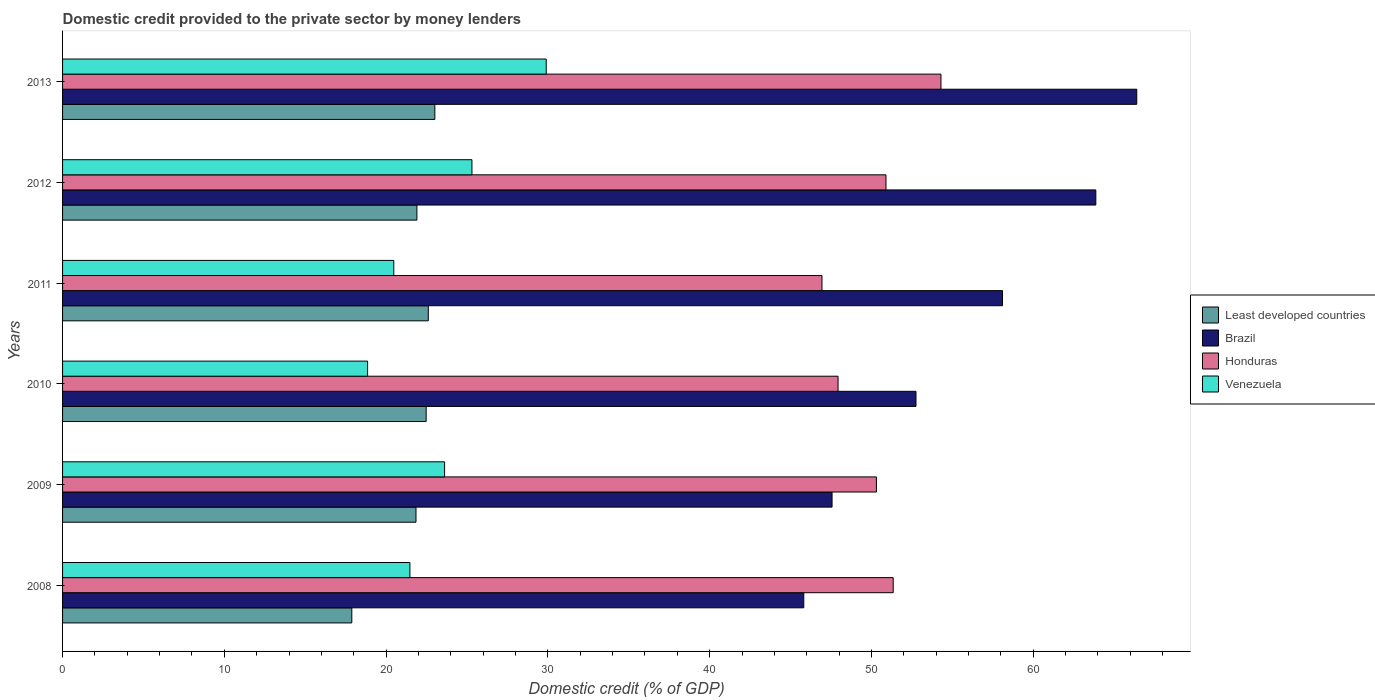How many different coloured bars are there?
Your response must be concise. 4. How many groups of bars are there?
Your response must be concise. 6. Are the number of bars per tick equal to the number of legend labels?
Your answer should be compact. Yes. How many bars are there on the 2nd tick from the top?
Make the answer very short. 4. How many bars are there on the 2nd tick from the bottom?
Your answer should be compact. 4. In how many cases, is the number of bars for a given year not equal to the number of legend labels?
Offer a very short reply. 0. What is the domestic credit provided to the private sector by money lenders in Honduras in 2010?
Provide a short and direct response. 47.93. Across all years, what is the maximum domestic credit provided to the private sector by money lenders in Brazil?
Keep it short and to the point. 66.4. Across all years, what is the minimum domestic credit provided to the private sector by money lenders in Least developed countries?
Give a very brief answer. 17.88. What is the total domestic credit provided to the private sector by money lenders in Brazil in the graph?
Your answer should be compact. 334.5. What is the difference between the domestic credit provided to the private sector by money lenders in Least developed countries in 2011 and that in 2012?
Ensure brevity in your answer.  0.7. What is the difference between the domestic credit provided to the private sector by money lenders in Brazil in 2010 and the domestic credit provided to the private sector by money lenders in Honduras in 2009?
Provide a short and direct response. 2.45. What is the average domestic credit provided to the private sector by money lenders in Least developed countries per year?
Your answer should be compact. 21.62. In the year 2013, what is the difference between the domestic credit provided to the private sector by money lenders in Venezuela and domestic credit provided to the private sector by money lenders in Brazil?
Offer a very short reply. -36.5. What is the ratio of the domestic credit provided to the private sector by money lenders in Brazil in 2011 to that in 2013?
Keep it short and to the point. 0.88. What is the difference between the highest and the second highest domestic credit provided to the private sector by money lenders in Least developed countries?
Your answer should be compact. 0.4. What is the difference between the highest and the lowest domestic credit provided to the private sector by money lenders in Venezuela?
Provide a succinct answer. 11.04. In how many years, is the domestic credit provided to the private sector by money lenders in Honduras greater than the average domestic credit provided to the private sector by money lenders in Honduras taken over all years?
Provide a succinct answer. 4. Is the sum of the domestic credit provided to the private sector by money lenders in Least developed countries in 2008 and 2012 greater than the maximum domestic credit provided to the private sector by money lenders in Honduras across all years?
Keep it short and to the point. No. What does the 3rd bar from the top in 2009 represents?
Keep it short and to the point. Brazil. What does the 4th bar from the bottom in 2012 represents?
Make the answer very short. Venezuela. How many bars are there?
Offer a very short reply. 24. Where does the legend appear in the graph?
Provide a short and direct response. Center right. What is the title of the graph?
Offer a very short reply. Domestic credit provided to the private sector by money lenders. What is the label or title of the X-axis?
Provide a succinct answer. Domestic credit (% of GDP). What is the Domestic credit (% of GDP) of Least developed countries in 2008?
Make the answer very short. 17.88. What is the Domestic credit (% of GDP) of Brazil in 2008?
Keep it short and to the point. 45.82. What is the Domestic credit (% of GDP) in Honduras in 2008?
Ensure brevity in your answer.  51.34. What is the Domestic credit (% of GDP) in Venezuela in 2008?
Provide a short and direct response. 21.47. What is the Domestic credit (% of GDP) in Least developed countries in 2009?
Ensure brevity in your answer.  21.85. What is the Domestic credit (% of GDP) of Brazil in 2009?
Keep it short and to the point. 47.56. What is the Domestic credit (% of GDP) in Honduras in 2009?
Your answer should be compact. 50.31. What is the Domestic credit (% of GDP) of Venezuela in 2009?
Keep it short and to the point. 23.61. What is the Domestic credit (% of GDP) in Least developed countries in 2010?
Give a very brief answer. 22.47. What is the Domestic credit (% of GDP) in Brazil in 2010?
Make the answer very short. 52.75. What is the Domestic credit (% of GDP) in Honduras in 2010?
Keep it short and to the point. 47.93. What is the Domestic credit (% of GDP) of Venezuela in 2010?
Give a very brief answer. 18.85. What is the Domestic credit (% of GDP) in Least developed countries in 2011?
Your answer should be very brief. 22.61. What is the Domestic credit (% of GDP) of Brazil in 2011?
Keep it short and to the point. 58.1. What is the Domestic credit (% of GDP) of Honduras in 2011?
Provide a succinct answer. 46.94. What is the Domestic credit (% of GDP) of Venezuela in 2011?
Provide a succinct answer. 20.47. What is the Domestic credit (% of GDP) of Least developed countries in 2012?
Offer a very short reply. 21.9. What is the Domestic credit (% of GDP) of Brazil in 2012?
Keep it short and to the point. 63.87. What is the Domestic credit (% of GDP) in Honduras in 2012?
Provide a succinct answer. 50.9. What is the Domestic credit (% of GDP) in Venezuela in 2012?
Ensure brevity in your answer.  25.3. What is the Domestic credit (% of GDP) in Least developed countries in 2013?
Keep it short and to the point. 23.01. What is the Domestic credit (% of GDP) of Brazil in 2013?
Offer a terse response. 66.4. What is the Domestic credit (% of GDP) in Honduras in 2013?
Provide a succinct answer. 54.3. What is the Domestic credit (% of GDP) of Venezuela in 2013?
Provide a succinct answer. 29.9. Across all years, what is the maximum Domestic credit (% of GDP) of Least developed countries?
Offer a very short reply. 23.01. Across all years, what is the maximum Domestic credit (% of GDP) of Brazil?
Make the answer very short. 66.4. Across all years, what is the maximum Domestic credit (% of GDP) in Honduras?
Make the answer very short. 54.3. Across all years, what is the maximum Domestic credit (% of GDP) of Venezuela?
Offer a terse response. 29.9. Across all years, what is the minimum Domestic credit (% of GDP) of Least developed countries?
Keep it short and to the point. 17.88. Across all years, what is the minimum Domestic credit (% of GDP) of Brazil?
Ensure brevity in your answer.  45.82. Across all years, what is the minimum Domestic credit (% of GDP) of Honduras?
Ensure brevity in your answer.  46.94. Across all years, what is the minimum Domestic credit (% of GDP) in Venezuela?
Offer a terse response. 18.85. What is the total Domestic credit (% of GDP) in Least developed countries in the graph?
Your answer should be very brief. 129.72. What is the total Domestic credit (% of GDP) in Brazil in the graph?
Keep it short and to the point. 334.5. What is the total Domestic credit (% of GDP) of Honduras in the graph?
Ensure brevity in your answer.  301.72. What is the total Domestic credit (% of GDP) of Venezuela in the graph?
Make the answer very short. 139.61. What is the difference between the Domestic credit (% of GDP) of Least developed countries in 2008 and that in 2009?
Offer a very short reply. -3.97. What is the difference between the Domestic credit (% of GDP) in Brazil in 2008 and that in 2009?
Your answer should be compact. -1.75. What is the difference between the Domestic credit (% of GDP) in Honduras in 2008 and that in 2009?
Give a very brief answer. 1.04. What is the difference between the Domestic credit (% of GDP) of Venezuela in 2008 and that in 2009?
Your response must be concise. -2.14. What is the difference between the Domestic credit (% of GDP) in Least developed countries in 2008 and that in 2010?
Your answer should be compact. -4.6. What is the difference between the Domestic credit (% of GDP) in Brazil in 2008 and that in 2010?
Give a very brief answer. -6.94. What is the difference between the Domestic credit (% of GDP) of Honduras in 2008 and that in 2010?
Give a very brief answer. 3.41. What is the difference between the Domestic credit (% of GDP) in Venezuela in 2008 and that in 2010?
Your answer should be very brief. 2.62. What is the difference between the Domestic credit (% of GDP) in Least developed countries in 2008 and that in 2011?
Provide a short and direct response. -4.73. What is the difference between the Domestic credit (% of GDP) of Brazil in 2008 and that in 2011?
Your answer should be very brief. -12.28. What is the difference between the Domestic credit (% of GDP) of Honduras in 2008 and that in 2011?
Make the answer very short. 4.4. What is the difference between the Domestic credit (% of GDP) in Least developed countries in 2008 and that in 2012?
Give a very brief answer. -4.02. What is the difference between the Domestic credit (% of GDP) in Brazil in 2008 and that in 2012?
Your response must be concise. -18.05. What is the difference between the Domestic credit (% of GDP) of Honduras in 2008 and that in 2012?
Provide a succinct answer. 0.45. What is the difference between the Domestic credit (% of GDP) of Venezuela in 2008 and that in 2012?
Make the answer very short. -3.83. What is the difference between the Domestic credit (% of GDP) in Least developed countries in 2008 and that in 2013?
Keep it short and to the point. -5.13. What is the difference between the Domestic credit (% of GDP) of Brazil in 2008 and that in 2013?
Offer a very short reply. -20.58. What is the difference between the Domestic credit (% of GDP) in Honduras in 2008 and that in 2013?
Ensure brevity in your answer.  -2.95. What is the difference between the Domestic credit (% of GDP) in Venezuela in 2008 and that in 2013?
Your answer should be compact. -8.43. What is the difference between the Domestic credit (% of GDP) in Least developed countries in 2009 and that in 2010?
Give a very brief answer. -0.63. What is the difference between the Domestic credit (% of GDP) in Brazil in 2009 and that in 2010?
Offer a terse response. -5.19. What is the difference between the Domestic credit (% of GDP) of Honduras in 2009 and that in 2010?
Ensure brevity in your answer.  2.37. What is the difference between the Domestic credit (% of GDP) of Venezuela in 2009 and that in 2010?
Your answer should be compact. 4.76. What is the difference between the Domestic credit (% of GDP) of Least developed countries in 2009 and that in 2011?
Provide a succinct answer. -0.76. What is the difference between the Domestic credit (% of GDP) of Brazil in 2009 and that in 2011?
Provide a short and direct response. -10.54. What is the difference between the Domestic credit (% of GDP) in Honduras in 2009 and that in 2011?
Your response must be concise. 3.37. What is the difference between the Domestic credit (% of GDP) in Venezuela in 2009 and that in 2011?
Your response must be concise. 3.14. What is the difference between the Domestic credit (% of GDP) of Least developed countries in 2009 and that in 2012?
Keep it short and to the point. -0.06. What is the difference between the Domestic credit (% of GDP) of Brazil in 2009 and that in 2012?
Ensure brevity in your answer.  -16.3. What is the difference between the Domestic credit (% of GDP) of Honduras in 2009 and that in 2012?
Offer a very short reply. -0.59. What is the difference between the Domestic credit (% of GDP) in Venezuela in 2009 and that in 2012?
Your response must be concise. -1.69. What is the difference between the Domestic credit (% of GDP) of Least developed countries in 2009 and that in 2013?
Give a very brief answer. -1.16. What is the difference between the Domestic credit (% of GDP) in Brazil in 2009 and that in 2013?
Offer a terse response. -18.83. What is the difference between the Domestic credit (% of GDP) in Honduras in 2009 and that in 2013?
Your response must be concise. -3.99. What is the difference between the Domestic credit (% of GDP) of Venezuela in 2009 and that in 2013?
Offer a terse response. -6.28. What is the difference between the Domestic credit (% of GDP) in Least developed countries in 2010 and that in 2011?
Provide a short and direct response. -0.13. What is the difference between the Domestic credit (% of GDP) in Brazil in 2010 and that in 2011?
Your answer should be compact. -5.35. What is the difference between the Domestic credit (% of GDP) in Honduras in 2010 and that in 2011?
Ensure brevity in your answer.  0.99. What is the difference between the Domestic credit (% of GDP) in Venezuela in 2010 and that in 2011?
Offer a terse response. -1.62. What is the difference between the Domestic credit (% of GDP) in Least developed countries in 2010 and that in 2012?
Your answer should be very brief. 0.57. What is the difference between the Domestic credit (% of GDP) in Brazil in 2010 and that in 2012?
Your response must be concise. -11.12. What is the difference between the Domestic credit (% of GDP) of Honduras in 2010 and that in 2012?
Keep it short and to the point. -2.96. What is the difference between the Domestic credit (% of GDP) of Venezuela in 2010 and that in 2012?
Keep it short and to the point. -6.45. What is the difference between the Domestic credit (% of GDP) in Least developed countries in 2010 and that in 2013?
Make the answer very short. -0.54. What is the difference between the Domestic credit (% of GDP) of Brazil in 2010 and that in 2013?
Provide a short and direct response. -13.65. What is the difference between the Domestic credit (% of GDP) of Honduras in 2010 and that in 2013?
Keep it short and to the point. -6.36. What is the difference between the Domestic credit (% of GDP) of Venezuela in 2010 and that in 2013?
Make the answer very short. -11.04. What is the difference between the Domestic credit (% of GDP) in Least developed countries in 2011 and that in 2012?
Ensure brevity in your answer.  0.7. What is the difference between the Domestic credit (% of GDP) of Brazil in 2011 and that in 2012?
Your answer should be compact. -5.77. What is the difference between the Domestic credit (% of GDP) in Honduras in 2011 and that in 2012?
Offer a terse response. -3.96. What is the difference between the Domestic credit (% of GDP) of Venezuela in 2011 and that in 2012?
Give a very brief answer. -4.83. What is the difference between the Domestic credit (% of GDP) in Least developed countries in 2011 and that in 2013?
Make the answer very short. -0.4. What is the difference between the Domestic credit (% of GDP) in Brazil in 2011 and that in 2013?
Offer a very short reply. -8.3. What is the difference between the Domestic credit (% of GDP) in Honduras in 2011 and that in 2013?
Offer a very short reply. -7.36. What is the difference between the Domestic credit (% of GDP) in Venezuela in 2011 and that in 2013?
Make the answer very short. -9.42. What is the difference between the Domestic credit (% of GDP) of Least developed countries in 2012 and that in 2013?
Offer a very short reply. -1.11. What is the difference between the Domestic credit (% of GDP) of Brazil in 2012 and that in 2013?
Provide a succinct answer. -2.53. What is the difference between the Domestic credit (% of GDP) of Honduras in 2012 and that in 2013?
Your answer should be very brief. -3.4. What is the difference between the Domestic credit (% of GDP) in Venezuela in 2012 and that in 2013?
Your response must be concise. -4.59. What is the difference between the Domestic credit (% of GDP) in Least developed countries in 2008 and the Domestic credit (% of GDP) in Brazil in 2009?
Provide a short and direct response. -29.68. What is the difference between the Domestic credit (% of GDP) in Least developed countries in 2008 and the Domestic credit (% of GDP) in Honduras in 2009?
Ensure brevity in your answer.  -32.43. What is the difference between the Domestic credit (% of GDP) of Least developed countries in 2008 and the Domestic credit (% of GDP) of Venezuela in 2009?
Make the answer very short. -5.73. What is the difference between the Domestic credit (% of GDP) of Brazil in 2008 and the Domestic credit (% of GDP) of Honduras in 2009?
Offer a very short reply. -4.49. What is the difference between the Domestic credit (% of GDP) in Brazil in 2008 and the Domestic credit (% of GDP) in Venezuela in 2009?
Your response must be concise. 22.2. What is the difference between the Domestic credit (% of GDP) in Honduras in 2008 and the Domestic credit (% of GDP) in Venezuela in 2009?
Your answer should be compact. 27.73. What is the difference between the Domestic credit (% of GDP) of Least developed countries in 2008 and the Domestic credit (% of GDP) of Brazil in 2010?
Keep it short and to the point. -34.87. What is the difference between the Domestic credit (% of GDP) in Least developed countries in 2008 and the Domestic credit (% of GDP) in Honduras in 2010?
Your answer should be compact. -30.05. What is the difference between the Domestic credit (% of GDP) of Least developed countries in 2008 and the Domestic credit (% of GDP) of Venezuela in 2010?
Your answer should be compact. -0.98. What is the difference between the Domestic credit (% of GDP) in Brazil in 2008 and the Domestic credit (% of GDP) in Honduras in 2010?
Provide a short and direct response. -2.12. What is the difference between the Domestic credit (% of GDP) in Brazil in 2008 and the Domestic credit (% of GDP) in Venezuela in 2010?
Your response must be concise. 26.96. What is the difference between the Domestic credit (% of GDP) of Honduras in 2008 and the Domestic credit (% of GDP) of Venezuela in 2010?
Keep it short and to the point. 32.49. What is the difference between the Domestic credit (% of GDP) of Least developed countries in 2008 and the Domestic credit (% of GDP) of Brazil in 2011?
Make the answer very short. -40.22. What is the difference between the Domestic credit (% of GDP) in Least developed countries in 2008 and the Domestic credit (% of GDP) in Honduras in 2011?
Make the answer very short. -29.06. What is the difference between the Domestic credit (% of GDP) in Least developed countries in 2008 and the Domestic credit (% of GDP) in Venezuela in 2011?
Your answer should be very brief. -2.6. What is the difference between the Domestic credit (% of GDP) in Brazil in 2008 and the Domestic credit (% of GDP) in Honduras in 2011?
Offer a terse response. -1.12. What is the difference between the Domestic credit (% of GDP) of Brazil in 2008 and the Domestic credit (% of GDP) of Venezuela in 2011?
Your answer should be very brief. 25.34. What is the difference between the Domestic credit (% of GDP) of Honduras in 2008 and the Domestic credit (% of GDP) of Venezuela in 2011?
Your answer should be compact. 30.87. What is the difference between the Domestic credit (% of GDP) of Least developed countries in 2008 and the Domestic credit (% of GDP) of Brazil in 2012?
Offer a very short reply. -45.99. What is the difference between the Domestic credit (% of GDP) in Least developed countries in 2008 and the Domestic credit (% of GDP) in Honduras in 2012?
Give a very brief answer. -33.02. What is the difference between the Domestic credit (% of GDP) in Least developed countries in 2008 and the Domestic credit (% of GDP) in Venezuela in 2012?
Your answer should be compact. -7.42. What is the difference between the Domestic credit (% of GDP) in Brazil in 2008 and the Domestic credit (% of GDP) in Honduras in 2012?
Ensure brevity in your answer.  -5.08. What is the difference between the Domestic credit (% of GDP) in Brazil in 2008 and the Domestic credit (% of GDP) in Venezuela in 2012?
Offer a terse response. 20.51. What is the difference between the Domestic credit (% of GDP) in Honduras in 2008 and the Domestic credit (% of GDP) in Venezuela in 2012?
Your answer should be very brief. 26.04. What is the difference between the Domestic credit (% of GDP) of Least developed countries in 2008 and the Domestic credit (% of GDP) of Brazil in 2013?
Offer a very short reply. -48.52. What is the difference between the Domestic credit (% of GDP) in Least developed countries in 2008 and the Domestic credit (% of GDP) in Honduras in 2013?
Your response must be concise. -36.42. What is the difference between the Domestic credit (% of GDP) in Least developed countries in 2008 and the Domestic credit (% of GDP) in Venezuela in 2013?
Your response must be concise. -12.02. What is the difference between the Domestic credit (% of GDP) of Brazil in 2008 and the Domestic credit (% of GDP) of Honduras in 2013?
Offer a terse response. -8.48. What is the difference between the Domestic credit (% of GDP) of Brazil in 2008 and the Domestic credit (% of GDP) of Venezuela in 2013?
Provide a short and direct response. 15.92. What is the difference between the Domestic credit (% of GDP) of Honduras in 2008 and the Domestic credit (% of GDP) of Venezuela in 2013?
Your answer should be very brief. 21.45. What is the difference between the Domestic credit (% of GDP) of Least developed countries in 2009 and the Domestic credit (% of GDP) of Brazil in 2010?
Give a very brief answer. -30.9. What is the difference between the Domestic credit (% of GDP) in Least developed countries in 2009 and the Domestic credit (% of GDP) in Honduras in 2010?
Your answer should be compact. -26.09. What is the difference between the Domestic credit (% of GDP) of Least developed countries in 2009 and the Domestic credit (% of GDP) of Venezuela in 2010?
Offer a terse response. 2.99. What is the difference between the Domestic credit (% of GDP) of Brazil in 2009 and the Domestic credit (% of GDP) of Honduras in 2010?
Keep it short and to the point. -0.37. What is the difference between the Domestic credit (% of GDP) in Brazil in 2009 and the Domestic credit (% of GDP) in Venezuela in 2010?
Provide a short and direct response. 28.71. What is the difference between the Domestic credit (% of GDP) in Honduras in 2009 and the Domestic credit (% of GDP) in Venezuela in 2010?
Offer a terse response. 31.45. What is the difference between the Domestic credit (% of GDP) in Least developed countries in 2009 and the Domestic credit (% of GDP) in Brazil in 2011?
Your answer should be compact. -36.25. What is the difference between the Domestic credit (% of GDP) in Least developed countries in 2009 and the Domestic credit (% of GDP) in Honduras in 2011?
Keep it short and to the point. -25.09. What is the difference between the Domestic credit (% of GDP) of Least developed countries in 2009 and the Domestic credit (% of GDP) of Venezuela in 2011?
Keep it short and to the point. 1.37. What is the difference between the Domestic credit (% of GDP) of Brazil in 2009 and the Domestic credit (% of GDP) of Honduras in 2011?
Ensure brevity in your answer.  0.62. What is the difference between the Domestic credit (% of GDP) in Brazil in 2009 and the Domestic credit (% of GDP) in Venezuela in 2011?
Offer a very short reply. 27.09. What is the difference between the Domestic credit (% of GDP) of Honduras in 2009 and the Domestic credit (% of GDP) of Venezuela in 2011?
Your response must be concise. 29.83. What is the difference between the Domestic credit (% of GDP) in Least developed countries in 2009 and the Domestic credit (% of GDP) in Brazil in 2012?
Offer a very short reply. -42.02. What is the difference between the Domestic credit (% of GDP) in Least developed countries in 2009 and the Domestic credit (% of GDP) in Honduras in 2012?
Your response must be concise. -29.05. What is the difference between the Domestic credit (% of GDP) in Least developed countries in 2009 and the Domestic credit (% of GDP) in Venezuela in 2012?
Ensure brevity in your answer.  -3.46. What is the difference between the Domestic credit (% of GDP) in Brazil in 2009 and the Domestic credit (% of GDP) in Honduras in 2012?
Keep it short and to the point. -3.33. What is the difference between the Domestic credit (% of GDP) of Brazil in 2009 and the Domestic credit (% of GDP) of Venezuela in 2012?
Keep it short and to the point. 22.26. What is the difference between the Domestic credit (% of GDP) in Honduras in 2009 and the Domestic credit (% of GDP) in Venezuela in 2012?
Give a very brief answer. 25. What is the difference between the Domestic credit (% of GDP) of Least developed countries in 2009 and the Domestic credit (% of GDP) of Brazil in 2013?
Provide a succinct answer. -44.55. What is the difference between the Domestic credit (% of GDP) of Least developed countries in 2009 and the Domestic credit (% of GDP) of Honduras in 2013?
Make the answer very short. -32.45. What is the difference between the Domestic credit (% of GDP) of Least developed countries in 2009 and the Domestic credit (% of GDP) of Venezuela in 2013?
Provide a succinct answer. -8.05. What is the difference between the Domestic credit (% of GDP) in Brazil in 2009 and the Domestic credit (% of GDP) in Honduras in 2013?
Keep it short and to the point. -6.73. What is the difference between the Domestic credit (% of GDP) of Brazil in 2009 and the Domestic credit (% of GDP) of Venezuela in 2013?
Your answer should be compact. 17.67. What is the difference between the Domestic credit (% of GDP) of Honduras in 2009 and the Domestic credit (% of GDP) of Venezuela in 2013?
Offer a very short reply. 20.41. What is the difference between the Domestic credit (% of GDP) of Least developed countries in 2010 and the Domestic credit (% of GDP) of Brazil in 2011?
Offer a very short reply. -35.63. What is the difference between the Domestic credit (% of GDP) in Least developed countries in 2010 and the Domestic credit (% of GDP) in Honduras in 2011?
Your response must be concise. -24.47. What is the difference between the Domestic credit (% of GDP) in Least developed countries in 2010 and the Domestic credit (% of GDP) in Venezuela in 2011?
Keep it short and to the point. 2. What is the difference between the Domestic credit (% of GDP) in Brazil in 2010 and the Domestic credit (% of GDP) in Honduras in 2011?
Give a very brief answer. 5.81. What is the difference between the Domestic credit (% of GDP) in Brazil in 2010 and the Domestic credit (% of GDP) in Venezuela in 2011?
Your response must be concise. 32.28. What is the difference between the Domestic credit (% of GDP) of Honduras in 2010 and the Domestic credit (% of GDP) of Venezuela in 2011?
Provide a short and direct response. 27.46. What is the difference between the Domestic credit (% of GDP) in Least developed countries in 2010 and the Domestic credit (% of GDP) in Brazil in 2012?
Ensure brevity in your answer.  -41.39. What is the difference between the Domestic credit (% of GDP) of Least developed countries in 2010 and the Domestic credit (% of GDP) of Honduras in 2012?
Offer a very short reply. -28.42. What is the difference between the Domestic credit (% of GDP) in Least developed countries in 2010 and the Domestic credit (% of GDP) in Venezuela in 2012?
Your response must be concise. -2.83. What is the difference between the Domestic credit (% of GDP) in Brazil in 2010 and the Domestic credit (% of GDP) in Honduras in 2012?
Make the answer very short. 1.85. What is the difference between the Domestic credit (% of GDP) in Brazil in 2010 and the Domestic credit (% of GDP) in Venezuela in 2012?
Your answer should be compact. 27.45. What is the difference between the Domestic credit (% of GDP) of Honduras in 2010 and the Domestic credit (% of GDP) of Venezuela in 2012?
Your answer should be compact. 22.63. What is the difference between the Domestic credit (% of GDP) in Least developed countries in 2010 and the Domestic credit (% of GDP) in Brazil in 2013?
Make the answer very short. -43.92. What is the difference between the Domestic credit (% of GDP) in Least developed countries in 2010 and the Domestic credit (% of GDP) in Honduras in 2013?
Offer a terse response. -31.82. What is the difference between the Domestic credit (% of GDP) in Least developed countries in 2010 and the Domestic credit (% of GDP) in Venezuela in 2013?
Ensure brevity in your answer.  -7.42. What is the difference between the Domestic credit (% of GDP) in Brazil in 2010 and the Domestic credit (% of GDP) in Honduras in 2013?
Provide a succinct answer. -1.54. What is the difference between the Domestic credit (% of GDP) in Brazil in 2010 and the Domestic credit (% of GDP) in Venezuela in 2013?
Make the answer very short. 22.86. What is the difference between the Domestic credit (% of GDP) in Honduras in 2010 and the Domestic credit (% of GDP) in Venezuela in 2013?
Your answer should be compact. 18.04. What is the difference between the Domestic credit (% of GDP) of Least developed countries in 2011 and the Domestic credit (% of GDP) of Brazil in 2012?
Make the answer very short. -41.26. What is the difference between the Domestic credit (% of GDP) in Least developed countries in 2011 and the Domestic credit (% of GDP) in Honduras in 2012?
Offer a terse response. -28.29. What is the difference between the Domestic credit (% of GDP) in Least developed countries in 2011 and the Domestic credit (% of GDP) in Venezuela in 2012?
Make the answer very short. -2.7. What is the difference between the Domestic credit (% of GDP) in Brazil in 2011 and the Domestic credit (% of GDP) in Honduras in 2012?
Give a very brief answer. 7.2. What is the difference between the Domestic credit (% of GDP) of Brazil in 2011 and the Domestic credit (% of GDP) of Venezuela in 2012?
Your response must be concise. 32.8. What is the difference between the Domestic credit (% of GDP) of Honduras in 2011 and the Domestic credit (% of GDP) of Venezuela in 2012?
Make the answer very short. 21.64. What is the difference between the Domestic credit (% of GDP) of Least developed countries in 2011 and the Domestic credit (% of GDP) of Brazil in 2013?
Provide a short and direct response. -43.79. What is the difference between the Domestic credit (% of GDP) of Least developed countries in 2011 and the Domestic credit (% of GDP) of Honduras in 2013?
Your answer should be very brief. -31.69. What is the difference between the Domestic credit (% of GDP) of Least developed countries in 2011 and the Domestic credit (% of GDP) of Venezuela in 2013?
Your response must be concise. -7.29. What is the difference between the Domestic credit (% of GDP) of Brazil in 2011 and the Domestic credit (% of GDP) of Honduras in 2013?
Give a very brief answer. 3.8. What is the difference between the Domestic credit (% of GDP) in Brazil in 2011 and the Domestic credit (% of GDP) in Venezuela in 2013?
Your answer should be very brief. 28.2. What is the difference between the Domestic credit (% of GDP) of Honduras in 2011 and the Domestic credit (% of GDP) of Venezuela in 2013?
Your response must be concise. 17.04. What is the difference between the Domestic credit (% of GDP) of Least developed countries in 2012 and the Domestic credit (% of GDP) of Brazil in 2013?
Your answer should be very brief. -44.5. What is the difference between the Domestic credit (% of GDP) of Least developed countries in 2012 and the Domestic credit (% of GDP) of Honduras in 2013?
Give a very brief answer. -32.39. What is the difference between the Domestic credit (% of GDP) of Least developed countries in 2012 and the Domestic credit (% of GDP) of Venezuela in 2013?
Provide a short and direct response. -7.99. What is the difference between the Domestic credit (% of GDP) in Brazil in 2012 and the Domestic credit (% of GDP) in Honduras in 2013?
Your answer should be very brief. 9.57. What is the difference between the Domestic credit (% of GDP) of Brazil in 2012 and the Domestic credit (% of GDP) of Venezuela in 2013?
Make the answer very short. 33.97. What is the difference between the Domestic credit (% of GDP) in Honduras in 2012 and the Domestic credit (% of GDP) in Venezuela in 2013?
Provide a succinct answer. 21. What is the average Domestic credit (% of GDP) in Least developed countries per year?
Your response must be concise. 21.62. What is the average Domestic credit (% of GDP) in Brazil per year?
Give a very brief answer. 55.75. What is the average Domestic credit (% of GDP) in Honduras per year?
Provide a succinct answer. 50.29. What is the average Domestic credit (% of GDP) in Venezuela per year?
Your response must be concise. 23.27. In the year 2008, what is the difference between the Domestic credit (% of GDP) in Least developed countries and Domestic credit (% of GDP) in Brazil?
Offer a terse response. -27.94. In the year 2008, what is the difference between the Domestic credit (% of GDP) of Least developed countries and Domestic credit (% of GDP) of Honduras?
Your answer should be very brief. -33.46. In the year 2008, what is the difference between the Domestic credit (% of GDP) of Least developed countries and Domestic credit (% of GDP) of Venezuela?
Ensure brevity in your answer.  -3.59. In the year 2008, what is the difference between the Domestic credit (% of GDP) in Brazil and Domestic credit (% of GDP) in Honduras?
Keep it short and to the point. -5.53. In the year 2008, what is the difference between the Domestic credit (% of GDP) of Brazil and Domestic credit (% of GDP) of Venezuela?
Make the answer very short. 24.35. In the year 2008, what is the difference between the Domestic credit (% of GDP) of Honduras and Domestic credit (% of GDP) of Venezuela?
Give a very brief answer. 29.87. In the year 2009, what is the difference between the Domestic credit (% of GDP) in Least developed countries and Domestic credit (% of GDP) in Brazil?
Your response must be concise. -25.72. In the year 2009, what is the difference between the Domestic credit (% of GDP) of Least developed countries and Domestic credit (% of GDP) of Honduras?
Give a very brief answer. -28.46. In the year 2009, what is the difference between the Domestic credit (% of GDP) in Least developed countries and Domestic credit (% of GDP) in Venezuela?
Provide a short and direct response. -1.77. In the year 2009, what is the difference between the Domestic credit (% of GDP) of Brazil and Domestic credit (% of GDP) of Honduras?
Provide a succinct answer. -2.74. In the year 2009, what is the difference between the Domestic credit (% of GDP) of Brazil and Domestic credit (% of GDP) of Venezuela?
Give a very brief answer. 23.95. In the year 2009, what is the difference between the Domestic credit (% of GDP) of Honduras and Domestic credit (% of GDP) of Venezuela?
Your answer should be compact. 26.69. In the year 2010, what is the difference between the Domestic credit (% of GDP) of Least developed countries and Domestic credit (% of GDP) of Brazil?
Offer a very short reply. -30.28. In the year 2010, what is the difference between the Domestic credit (% of GDP) of Least developed countries and Domestic credit (% of GDP) of Honduras?
Provide a short and direct response. -25.46. In the year 2010, what is the difference between the Domestic credit (% of GDP) in Least developed countries and Domestic credit (% of GDP) in Venezuela?
Ensure brevity in your answer.  3.62. In the year 2010, what is the difference between the Domestic credit (% of GDP) in Brazil and Domestic credit (% of GDP) in Honduras?
Your response must be concise. 4.82. In the year 2010, what is the difference between the Domestic credit (% of GDP) in Brazil and Domestic credit (% of GDP) in Venezuela?
Your answer should be very brief. 33.9. In the year 2010, what is the difference between the Domestic credit (% of GDP) of Honduras and Domestic credit (% of GDP) of Venezuela?
Ensure brevity in your answer.  29.08. In the year 2011, what is the difference between the Domestic credit (% of GDP) of Least developed countries and Domestic credit (% of GDP) of Brazil?
Your response must be concise. -35.49. In the year 2011, what is the difference between the Domestic credit (% of GDP) of Least developed countries and Domestic credit (% of GDP) of Honduras?
Keep it short and to the point. -24.33. In the year 2011, what is the difference between the Domestic credit (% of GDP) of Least developed countries and Domestic credit (% of GDP) of Venezuela?
Make the answer very short. 2.13. In the year 2011, what is the difference between the Domestic credit (% of GDP) in Brazil and Domestic credit (% of GDP) in Honduras?
Keep it short and to the point. 11.16. In the year 2011, what is the difference between the Domestic credit (% of GDP) in Brazil and Domestic credit (% of GDP) in Venezuela?
Ensure brevity in your answer.  37.63. In the year 2011, what is the difference between the Domestic credit (% of GDP) in Honduras and Domestic credit (% of GDP) in Venezuela?
Offer a terse response. 26.47. In the year 2012, what is the difference between the Domestic credit (% of GDP) of Least developed countries and Domestic credit (% of GDP) of Brazil?
Make the answer very short. -41.97. In the year 2012, what is the difference between the Domestic credit (% of GDP) of Least developed countries and Domestic credit (% of GDP) of Honduras?
Offer a terse response. -28.99. In the year 2012, what is the difference between the Domestic credit (% of GDP) in Least developed countries and Domestic credit (% of GDP) in Venezuela?
Provide a short and direct response. -3.4. In the year 2012, what is the difference between the Domestic credit (% of GDP) of Brazil and Domestic credit (% of GDP) of Honduras?
Offer a very short reply. 12.97. In the year 2012, what is the difference between the Domestic credit (% of GDP) in Brazil and Domestic credit (% of GDP) in Venezuela?
Offer a terse response. 38.56. In the year 2012, what is the difference between the Domestic credit (% of GDP) of Honduras and Domestic credit (% of GDP) of Venezuela?
Your answer should be very brief. 25.59. In the year 2013, what is the difference between the Domestic credit (% of GDP) in Least developed countries and Domestic credit (% of GDP) in Brazil?
Offer a very short reply. -43.39. In the year 2013, what is the difference between the Domestic credit (% of GDP) of Least developed countries and Domestic credit (% of GDP) of Honduras?
Ensure brevity in your answer.  -31.28. In the year 2013, what is the difference between the Domestic credit (% of GDP) in Least developed countries and Domestic credit (% of GDP) in Venezuela?
Ensure brevity in your answer.  -6.89. In the year 2013, what is the difference between the Domestic credit (% of GDP) of Brazil and Domestic credit (% of GDP) of Honduras?
Give a very brief answer. 12.1. In the year 2013, what is the difference between the Domestic credit (% of GDP) of Brazil and Domestic credit (% of GDP) of Venezuela?
Provide a short and direct response. 36.5. In the year 2013, what is the difference between the Domestic credit (% of GDP) in Honduras and Domestic credit (% of GDP) in Venezuela?
Offer a very short reply. 24.4. What is the ratio of the Domestic credit (% of GDP) in Least developed countries in 2008 to that in 2009?
Offer a terse response. 0.82. What is the ratio of the Domestic credit (% of GDP) in Brazil in 2008 to that in 2009?
Your answer should be compact. 0.96. What is the ratio of the Domestic credit (% of GDP) in Honduras in 2008 to that in 2009?
Your answer should be very brief. 1.02. What is the ratio of the Domestic credit (% of GDP) of Venezuela in 2008 to that in 2009?
Offer a terse response. 0.91. What is the ratio of the Domestic credit (% of GDP) in Least developed countries in 2008 to that in 2010?
Ensure brevity in your answer.  0.8. What is the ratio of the Domestic credit (% of GDP) in Brazil in 2008 to that in 2010?
Offer a very short reply. 0.87. What is the ratio of the Domestic credit (% of GDP) in Honduras in 2008 to that in 2010?
Provide a succinct answer. 1.07. What is the ratio of the Domestic credit (% of GDP) in Venezuela in 2008 to that in 2010?
Offer a terse response. 1.14. What is the ratio of the Domestic credit (% of GDP) of Least developed countries in 2008 to that in 2011?
Ensure brevity in your answer.  0.79. What is the ratio of the Domestic credit (% of GDP) in Brazil in 2008 to that in 2011?
Provide a succinct answer. 0.79. What is the ratio of the Domestic credit (% of GDP) of Honduras in 2008 to that in 2011?
Provide a short and direct response. 1.09. What is the ratio of the Domestic credit (% of GDP) of Venezuela in 2008 to that in 2011?
Provide a succinct answer. 1.05. What is the ratio of the Domestic credit (% of GDP) of Least developed countries in 2008 to that in 2012?
Ensure brevity in your answer.  0.82. What is the ratio of the Domestic credit (% of GDP) in Brazil in 2008 to that in 2012?
Your response must be concise. 0.72. What is the ratio of the Domestic credit (% of GDP) in Honduras in 2008 to that in 2012?
Offer a terse response. 1.01. What is the ratio of the Domestic credit (% of GDP) in Venezuela in 2008 to that in 2012?
Make the answer very short. 0.85. What is the ratio of the Domestic credit (% of GDP) in Least developed countries in 2008 to that in 2013?
Give a very brief answer. 0.78. What is the ratio of the Domestic credit (% of GDP) of Brazil in 2008 to that in 2013?
Make the answer very short. 0.69. What is the ratio of the Domestic credit (% of GDP) in Honduras in 2008 to that in 2013?
Your response must be concise. 0.95. What is the ratio of the Domestic credit (% of GDP) in Venezuela in 2008 to that in 2013?
Keep it short and to the point. 0.72. What is the ratio of the Domestic credit (% of GDP) in Least developed countries in 2009 to that in 2010?
Your answer should be compact. 0.97. What is the ratio of the Domestic credit (% of GDP) of Brazil in 2009 to that in 2010?
Keep it short and to the point. 0.9. What is the ratio of the Domestic credit (% of GDP) in Honduras in 2009 to that in 2010?
Provide a succinct answer. 1.05. What is the ratio of the Domestic credit (% of GDP) in Venezuela in 2009 to that in 2010?
Your answer should be very brief. 1.25. What is the ratio of the Domestic credit (% of GDP) of Least developed countries in 2009 to that in 2011?
Your answer should be very brief. 0.97. What is the ratio of the Domestic credit (% of GDP) in Brazil in 2009 to that in 2011?
Offer a terse response. 0.82. What is the ratio of the Domestic credit (% of GDP) of Honduras in 2009 to that in 2011?
Your answer should be compact. 1.07. What is the ratio of the Domestic credit (% of GDP) in Venezuela in 2009 to that in 2011?
Provide a succinct answer. 1.15. What is the ratio of the Domestic credit (% of GDP) of Least developed countries in 2009 to that in 2012?
Keep it short and to the point. 1. What is the ratio of the Domestic credit (% of GDP) in Brazil in 2009 to that in 2012?
Offer a very short reply. 0.74. What is the ratio of the Domestic credit (% of GDP) in Honduras in 2009 to that in 2012?
Your answer should be compact. 0.99. What is the ratio of the Domestic credit (% of GDP) of Venezuela in 2009 to that in 2012?
Provide a succinct answer. 0.93. What is the ratio of the Domestic credit (% of GDP) of Least developed countries in 2009 to that in 2013?
Your response must be concise. 0.95. What is the ratio of the Domestic credit (% of GDP) in Brazil in 2009 to that in 2013?
Ensure brevity in your answer.  0.72. What is the ratio of the Domestic credit (% of GDP) in Honduras in 2009 to that in 2013?
Your response must be concise. 0.93. What is the ratio of the Domestic credit (% of GDP) of Venezuela in 2009 to that in 2013?
Provide a succinct answer. 0.79. What is the ratio of the Domestic credit (% of GDP) in Brazil in 2010 to that in 2011?
Make the answer very short. 0.91. What is the ratio of the Domestic credit (% of GDP) of Honduras in 2010 to that in 2011?
Your answer should be very brief. 1.02. What is the ratio of the Domestic credit (% of GDP) of Venezuela in 2010 to that in 2011?
Give a very brief answer. 0.92. What is the ratio of the Domestic credit (% of GDP) in Least developed countries in 2010 to that in 2012?
Keep it short and to the point. 1.03. What is the ratio of the Domestic credit (% of GDP) of Brazil in 2010 to that in 2012?
Provide a short and direct response. 0.83. What is the ratio of the Domestic credit (% of GDP) in Honduras in 2010 to that in 2012?
Make the answer very short. 0.94. What is the ratio of the Domestic credit (% of GDP) of Venezuela in 2010 to that in 2012?
Your answer should be very brief. 0.75. What is the ratio of the Domestic credit (% of GDP) of Least developed countries in 2010 to that in 2013?
Provide a short and direct response. 0.98. What is the ratio of the Domestic credit (% of GDP) in Brazil in 2010 to that in 2013?
Make the answer very short. 0.79. What is the ratio of the Domestic credit (% of GDP) of Honduras in 2010 to that in 2013?
Offer a very short reply. 0.88. What is the ratio of the Domestic credit (% of GDP) in Venezuela in 2010 to that in 2013?
Ensure brevity in your answer.  0.63. What is the ratio of the Domestic credit (% of GDP) of Least developed countries in 2011 to that in 2012?
Give a very brief answer. 1.03. What is the ratio of the Domestic credit (% of GDP) of Brazil in 2011 to that in 2012?
Offer a terse response. 0.91. What is the ratio of the Domestic credit (% of GDP) in Honduras in 2011 to that in 2012?
Provide a succinct answer. 0.92. What is the ratio of the Domestic credit (% of GDP) in Venezuela in 2011 to that in 2012?
Your answer should be very brief. 0.81. What is the ratio of the Domestic credit (% of GDP) in Least developed countries in 2011 to that in 2013?
Provide a succinct answer. 0.98. What is the ratio of the Domestic credit (% of GDP) of Brazil in 2011 to that in 2013?
Your answer should be compact. 0.88. What is the ratio of the Domestic credit (% of GDP) of Honduras in 2011 to that in 2013?
Provide a short and direct response. 0.86. What is the ratio of the Domestic credit (% of GDP) of Venezuela in 2011 to that in 2013?
Offer a very short reply. 0.68. What is the ratio of the Domestic credit (% of GDP) in Least developed countries in 2012 to that in 2013?
Your response must be concise. 0.95. What is the ratio of the Domestic credit (% of GDP) in Brazil in 2012 to that in 2013?
Give a very brief answer. 0.96. What is the ratio of the Domestic credit (% of GDP) of Honduras in 2012 to that in 2013?
Give a very brief answer. 0.94. What is the ratio of the Domestic credit (% of GDP) in Venezuela in 2012 to that in 2013?
Your response must be concise. 0.85. What is the difference between the highest and the second highest Domestic credit (% of GDP) of Least developed countries?
Ensure brevity in your answer.  0.4. What is the difference between the highest and the second highest Domestic credit (% of GDP) of Brazil?
Keep it short and to the point. 2.53. What is the difference between the highest and the second highest Domestic credit (% of GDP) of Honduras?
Offer a terse response. 2.95. What is the difference between the highest and the second highest Domestic credit (% of GDP) in Venezuela?
Provide a short and direct response. 4.59. What is the difference between the highest and the lowest Domestic credit (% of GDP) of Least developed countries?
Give a very brief answer. 5.13. What is the difference between the highest and the lowest Domestic credit (% of GDP) in Brazil?
Ensure brevity in your answer.  20.58. What is the difference between the highest and the lowest Domestic credit (% of GDP) in Honduras?
Give a very brief answer. 7.36. What is the difference between the highest and the lowest Domestic credit (% of GDP) of Venezuela?
Offer a very short reply. 11.04. 